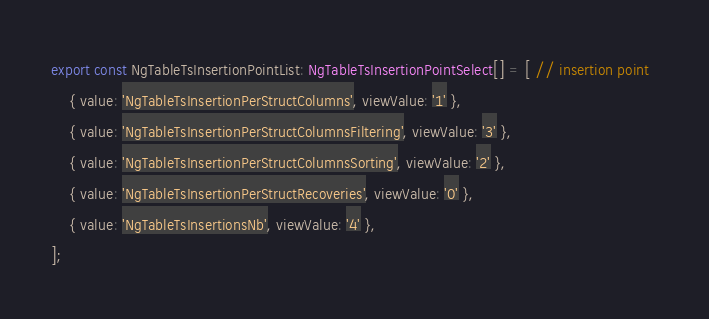<code> <loc_0><loc_0><loc_500><loc_500><_TypeScript_>export const NgTableTsInsertionPointList: NgTableTsInsertionPointSelect[] = [ // insertion point	
	{ value: 'NgTableTsInsertionPerStructColumns', viewValue: '1' },
	{ value: 'NgTableTsInsertionPerStructColumnsFiltering', viewValue: '3' },
	{ value: 'NgTableTsInsertionPerStructColumnsSorting', viewValue: '2' },
	{ value: 'NgTableTsInsertionPerStructRecoveries', viewValue: '0' },
	{ value: 'NgTableTsInsertionsNb', viewValue: '4' },
];
</code> 